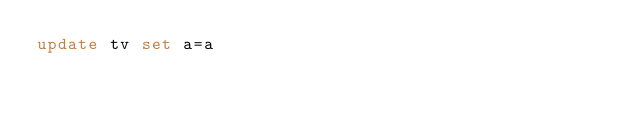<code> <loc_0><loc_0><loc_500><loc_500><_SQL_>update tv set a=a
</code> 